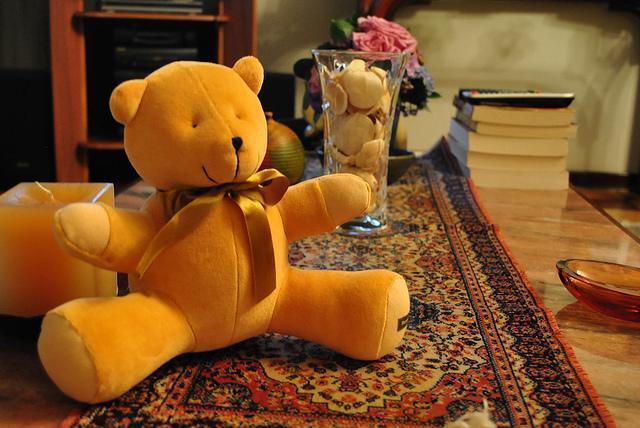How many cups can you see?
Give a very brief answer. 1. How many dining tables are visible?
Give a very brief answer. 1. How many books are there?
Give a very brief answer. 2. How many zebras are in the image?
Give a very brief answer. 0. 